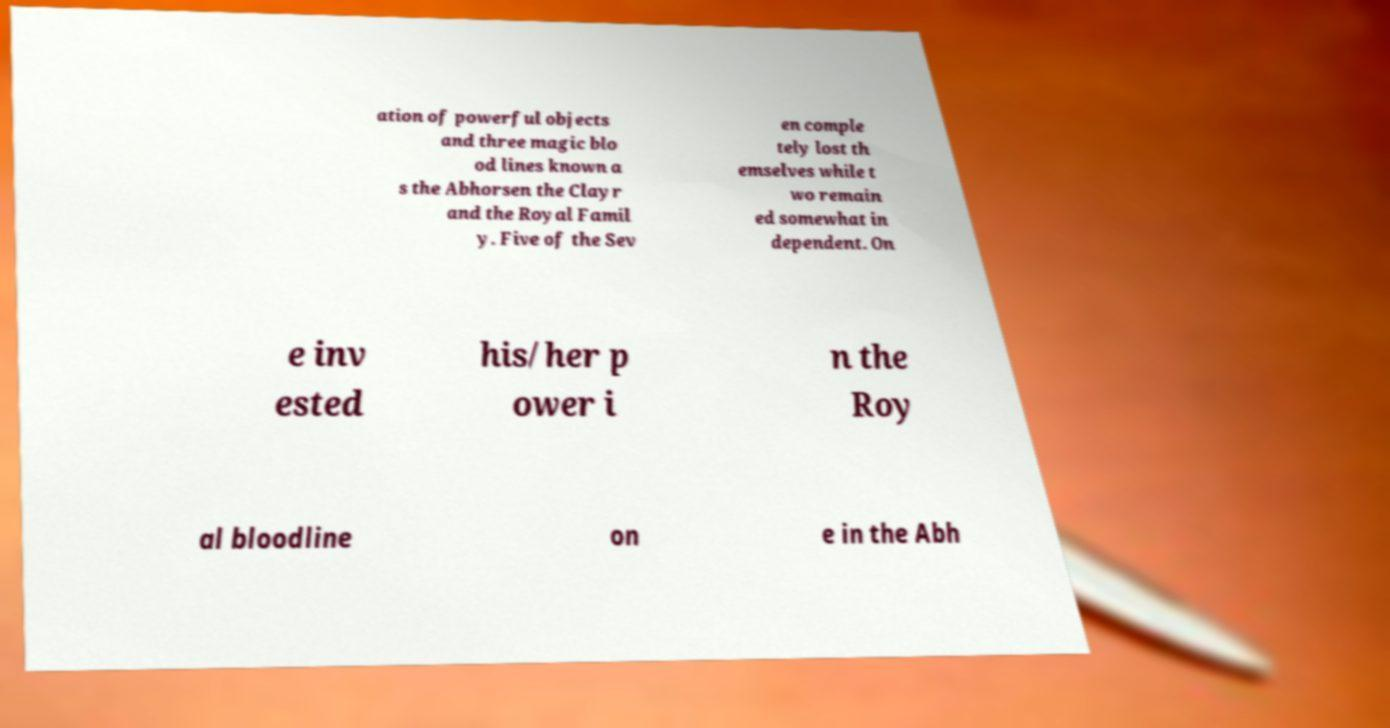I need the written content from this picture converted into text. Can you do that? ation of powerful objects and three magic blo od lines known a s the Abhorsen the Clayr and the Royal Famil y. Five of the Sev en comple tely lost th emselves while t wo remain ed somewhat in dependent. On e inv ested his/her p ower i n the Roy al bloodline on e in the Abh 